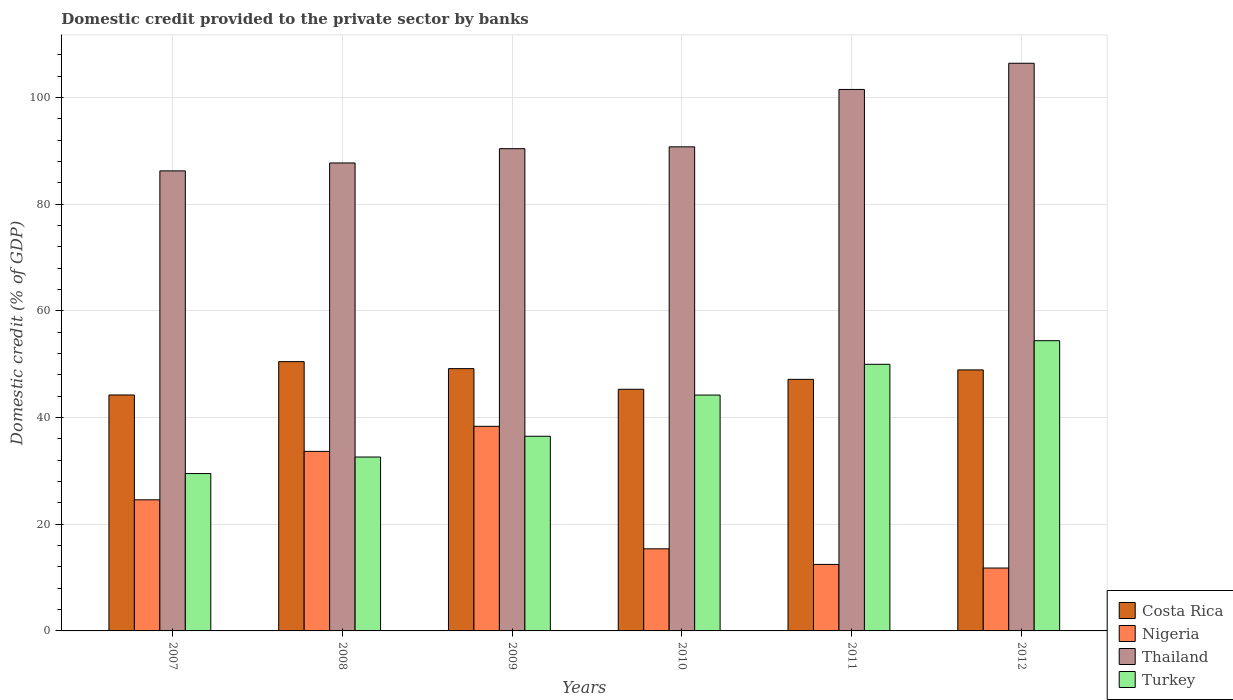How many groups of bars are there?
Your answer should be very brief. 6. Are the number of bars on each tick of the X-axis equal?
Offer a very short reply. Yes. How many bars are there on the 3rd tick from the right?
Provide a succinct answer. 4. What is the label of the 4th group of bars from the left?
Keep it short and to the point. 2010. What is the domestic credit provided to the private sector by banks in Turkey in 2011?
Offer a terse response. 49.97. Across all years, what is the maximum domestic credit provided to the private sector by banks in Costa Rica?
Offer a terse response. 50.47. Across all years, what is the minimum domestic credit provided to the private sector by banks in Thailand?
Your answer should be compact. 86.23. What is the total domestic credit provided to the private sector by banks in Thailand in the graph?
Provide a succinct answer. 562.93. What is the difference between the domestic credit provided to the private sector by banks in Turkey in 2010 and that in 2012?
Your answer should be very brief. -10.19. What is the difference between the domestic credit provided to the private sector by banks in Turkey in 2009 and the domestic credit provided to the private sector by banks in Thailand in 2012?
Offer a terse response. -69.91. What is the average domestic credit provided to the private sector by banks in Costa Rica per year?
Offer a very short reply. 47.54. In the year 2009, what is the difference between the domestic credit provided to the private sector by banks in Costa Rica and domestic credit provided to the private sector by banks in Thailand?
Keep it short and to the point. -41.23. What is the ratio of the domestic credit provided to the private sector by banks in Turkey in 2009 to that in 2010?
Your answer should be very brief. 0.83. What is the difference between the highest and the second highest domestic credit provided to the private sector by banks in Nigeria?
Your response must be concise. 4.69. What is the difference between the highest and the lowest domestic credit provided to the private sector by banks in Thailand?
Ensure brevity in your answer.  20.17. In how many years, is the domestic credit provided to the private sector by banks in Nigeria greater than the average domestic credit provided to the private sector by banks in Nigeria taken over all years?
Provide a succinct answer. 3. What does the 4th bar from the left in 2007 represents?
Offer a very short reply. Turkey. Is it the case that in every year, the sum of the domestic credit provided to the private sector by banks in Thailand and domestic credit provided to the private sector by banks in Turkey is greater than the domestic credit provided to the private sector by banks in Costa Rica?
Offer a terse response. Yes. How many bars are there?
Your answer should be compact. 24. How many years are there in the graph?
Your answer should be compact. 6. What is the difference between two consecutive major ticks on the Y-axis?
Your answer should be very brief. 20. Are the values on the major ticks of Y-axis written in scientific E-notation?
Provide a short and direct response. No. Does the graph contain any zero values?
Keep it short and to the point. No. Where does the legend appear in the graph?
Provide a short and direct response. Bottom right. How are the legend labels stacked?
Make the answer very short. Vertical. What is the title of the graph?
Your response must be concise. Domestic credit provided to the private sector by banks. Does "Samoa" appear as one of the legend labels in the graph?
Your response must be concise. No. What is the label or title of the Y-axis?
Give a very brief answer. Domestic credit (% of GDP). What is the Domestic credit (% of GDP) in Costa Rica in 2007?
Provide a short and direct response. 44.22. What is the Domestic credit (% of GDP) of Nigeria in 2007?
Ensure brevity in your answer.  24.57. What is the Domestic credit (% of GDP) in Thailand in 2007?
Provide a short and direct response. 86.23. What is the Domestic credit (% of GDP) of Turkey in 2007?
Give a very brief answer. 29.5. What is the Domestic credit (% of GDP) in Costa Rica in 2008?
Your answer should be very brief. 50.47. What is the Domestic credit (% of GDP) in Nigeria in 2008?
Your answer should be compact. 33.65. What is the Domestic credit (% of GDP) in Thailand in 2008?
Your response must be concise. 87.71. What is the Domestic credit (% of GDP) in Turkey in 2008?
Give a very brief answer. 32.59. What is the Domestic credit (% of GDP) of Costa Rica in 2009?
Give a very brief answer. 49.16. What is the Domestic credit (% of GDP) in Nigeria in 2009?
Your answer should be very brief. 38.35. What is the Domestic credit (% of GDP) in Thailand in 2009?
Keep it short and to the point. 90.38. What is the Domestic credit (% of GDP) of Turkey in 2009?
Offer a very short reply. 36.48. What is the Domestic credit (% of GDP) of Costa Rica in 2010?
Your response must be concise. 45.29. What is the Domestic credit (% of GDP) of Nigeria in 2010?
Your answer should be compact. 15.39. What is the Domestic credit (% of GDP) in Thailand in 2010?
Provide a succinct answer. 90.73. What is the Domestic credit (% of GDP) of Turkey in 2010?
Offer a terse response. 44.21. What is the Domestic credit (% of GDP) in Costa Rica in 2011?
Your response must be concise. 47.15. What is the Domestic credit (% of GDP) in Nigeria in 2011?
Your answer should be compact. 12.46. What is the Domestic credit (% of GDP) of Thailand in 2011?
Provide a short and direct response. 101.49. What is the Domestic credit (% of GDP) in Turkey in 2011?
Your answer should be compact. 49.97. What is the Domestic credit (% of GDP) of Costa Rica in 2012?
Keep it short and to the point. 48.92. What is the Domestic credit (% of GDP) in Nigeria in 2012?
Your response must be concise. 11.79. What is the Domestic credit (% of GDP) of Thailand in 2012?
Offer a terse response. 106.4. What is the Domestic credit (% of GDP) in Turkey in 2012?
Provide a succinct answer. 54.4. Across all years, what is the maximum Domestic credit (% of GDP) in Costa Rica?
Make the answer very short. 50.47. Across all years, what is the maximum Domestic credit (% of GDP) of Nigeria?
Provide a short and direct response. 38.35. Across all years, what is the maximum Domestic credit (% of GDP) in Thailand?
Offer a terse response. 106.4. Across all years, what is the maximum Domestic credit (% of GDP) in Turkey?
Give a very brief answer. 54.4. Across all years, what is the minimum Domestic credit (% of GDP) of Costa Rica?
Keep it short and to the point. 44.22. Across all years, what is the minimum Domestic credit (% of GDP) of Nigeria?
Your answer should be very brief. 11.79. Across all years, what is the minimum Domestic credit (% of GDP) of Thailand?
Your response must be concise. 86.23. Across all years, what is the minimum Domestic credit (% of GDP) of Turkey?
Ensure brevity in your answer.  29.5. What is the total Domestic credit (% of GDP) in Costa Rica in the graph?
Provide a succinct answer. 285.22. What is the total Domestic credit (% of GDP) in Nigeria in the graph?
Offer a very short reply. 136.22. What is the total Domestic credit (% of GDP) of Thailand in the graph?
Provide a short and direct response. 562.93. What is the total Domestic credit (% of GDP) of Turkey in the graph?
Provide a short and direct response. 247.15. What is the difference between the Domestic credit (% of GDP) of Costa Rica in 2007 and that in 2008?
Make the answer very short. -6.25. What is the difference between the Domestic credit (% of GDP) in Nigeria in 2007 and that in 2008?
Your answer should be compact. -9.08. What is the difference between the Domestic credit (% of GDP) in Thailand in 2007 and that in 2008?
Provide a succinct answer. -1.48. What is the difference between the Domestic credit (% of GDP) of Turkey in 2007 and that in 2008?
Ensure brevity in your answer.  -3.1. What is the difference between the Domestic credit (% of GDP) of Costa Rica in 2007 and that in 2009?
Your answer should be compact. -4.94. What is the difference between the Domestic credit (% of GDP) of Nigeria in 2007 and that in 2009?
Offer a very short reply. -13.78. What is the difference between the Domestic credit (% of GDP) of Thailand in 2007 and that in 2009?
Provide a short and direct response. -4.16. What is the difference between the Domestic credit (% of GDP) of Turkey in 2007 and that in 2009?
Your response must be concise. -6.99. What is the difference between the Domestic credit (% of GDP) of Costa Rica in 2007 and that in 2010?
Your response must be concise. -1.07. What is the difference between the Domestic credit (% of GDP) in Nigeria in 2007 and that in 2010?
Provide a succinct answer. 9.18. What is the difference between the Domestic credit (% of GDP) in Thailand in 2007 and that in 2010?
Your answer should be very brief. -4.5. What is the difference between the Domestic credit (% of GDP) in Turkey in 2007 and that in 2010?
Your answer should be very brief. -14.71. What is the difference between the Domestic credit (% of GDP) in Costa Rica in 2007 and that in 2011?
Your response must be concise. -2.93. What is the difference between the Domestic credit (% of GDP) of Nigeria in 2007 and that in 2011?
Offer a terse response. 12.11. What is the difference between the Domestic credit (% of GDP) of Thailand in 2007 and that in 2011?
Your answer should be very brief. -15.26. What is the difference between the Domestic credit (% of GDP) of Turkey in 2007 and that in 2011?
Your response must be concise. -20.48. What is the difference between the Domestic credit (% of GDP) in Costa Rica in 2007 and that in 2012?
Give a very brief answer. -4.7. What is the difference between the Domestic credit (% of GDP) of Nigeria in 2007 and that in 2012?
Provide a short and direct response. 12.78. What is the difference between the Domestic credit (% of GDP) of Thailand in 2007 and that in 2012?
Offer a very short reply. -20.17. What is the difference between the Domestic credit (% of GDP) of Turkey in 2007 and that in 2012?
Provide a succinct answer. -24.9. What is the difference between the Domestic credit (% of GDP) in Costa Rica in 2008 and that in 2009?
Your answer should be compact. 1.31. What is the difference between the Domestic credit (% of GDP) of Nigeria in 2008 and that in 2009?
Give a very brief answer. -4.69. What is the difference between the Domestic credit (% of GDP) in Thailand in 2008 and that in 2009?
Make the answer very short. -2.68. What is the difference between the Domestic credit (% of GDP) of Turkey in 2008 and that in 2009?
Give a very brief answer. -3.89. What is the difference between the Domestic credit (% of GDP) in Costa Rica in 2008 and that in 2010?
Give a very brief answer. 5.18. What is the difference between the Domestic credit (% of GDP) in Nigeria in 2008 and that in 2010?
Give a very brief answer. 18.26. What is the difference between the Domestic credit (% of GDP) of Thailand in 2008 and that in 2010?
Keep it short and to the point. -3.02. What is the difference between the Domestic credit (% of GDP) of Turkey in 2008 and that in 2010?
Ensure brevity in your answer.  -11.61. What is the difference between the Domestic credit (% of GDP) of Costa Rica in 2008 and that in 2011?
Offer a terse response. 3.32. What is the difference between the Domestic credit (% of GDP) of Nigeria in 2008 and that in 2011?
Offer a very short reply. 21.19. What is the difference between the Domestic credit (% of GDP) of Thailand in 2008 and that in 2011?
Your answer should be very brief. -13.78. What is the difference between the Domestic credit (% of GDP) of Turkey in 2008 and that in 2011?
Offer a terse response. -17.38. What is the difference between the Domestic credit (% of GDP) in Costa Rica in 2008 and that in 2012?
Make the answer very short. 1.55. What is the difference between the Domestic credit (% of GDP) in Nigeria in 2008 and that in 2012?
Offer a terse response. 21.87. What is the difference between the Domestic credit (% of GDP) of Thailand in 2008 and that in 2012?
Your response must be concise. -18.69. What is the difference between the Domestic credit (% of GDP) in Turkey in 2008 and that in 2012?
Make the answer very short. -21.8. What is the difference between the Domestic credit (% of GDP) of Costa Rica in 2009 and that in 2010?
Your answer should be compact. 3.87. What is the difference between the Domestic credit (% of GDP) of Nigeria in 2009 and that in 2010?
Make the answer very short. 22.96. What is the difference between the Domestic credit (% of GDP) of Thailand in 2009 and that in 2010?
Your answer should be very brief. -0.35. What is the difference between the Domestic credit (% of GDP) in Turkey in 2009 and that in 2010?
Ensure brevity in your answer.  -7.72. What is the difference between the Domestic credit (% of GDP) of Costa Rica in 2009 and that in 2011?
Offer a very short reply. 2.01. What is the difference between the Domestic credit (% of GDP) of Nigeria in 2009 and that in 2011?
Provide a succinct answer. 25.88. What is the difference between the Domestic credit (% of GDP) in Thailand in 2009 and that in 2011?
Ensure brevity in your answer.  -11.1. What is the difference between the Domestic credit (% of GDP) of Turkey in 2009 and that in 2011?
Ensure brevity in your answer.  -13.49. What is the difference between the Domestic credit (% of GDP) in Costa Rica in 2009 and that in 2012?
Ensure brevity in your answer.  0.24. What is the difference between the Domestic credit (% of GDP) of Nigeria in 2009 and that in 2012?
Your response must be concise. 26.56. What is the difference between the Domestic credit (% of GDP) of Thailand in 2009 and that in 2012?
Your answer should be very brief. -16.01. What is the difference between the Domestic credit (% of GDP) in Turkey in 2009 and that in 2012?
Make the answer very short. -17.91. What is the difference between the Domestic credit (% of GDP) in Costa Rica in 2010 and that in 2011?
Your answer should be compact. -1.86. What is the difference between the Domestic credit (% of GDP) of Nigeria in 2010 and that in 2011?
Offer a terse response. 2.93. What is the difference between the Domestic credit (% of GDP) of Thailand in 2010 and that in 2011?
Provide a succinct answer. -10.76. What is the difference between the Domestic credit (% of GDP) of Turkey in 2010 and that in 2011?
Offer a very short reply. -5.77. What is the difference between the Domestic credit (% of GDP) of Costa Rica in 2010 and that in 2012?
Provide a short and direct response. -3.63. What is the difference between the Domestic credit (% of GDP) of Nigeria in 2010 and that in 2012?
Give a very brief answer. 3.6. What is the difference between the Domestic credit (% of GDP) of Thailand in 2010 and that in 2012?
Ensure brevity in your answer.  -15.66. What is the difference between the Domestic credit (% of GDP) of Turkey in 2010 and that in 2012?
Make the answer very short. -10.19. What is the difference between the Domestic credit (% of GDP) of Costa Rica in 2011 and that in 2012?
Offer a very short reply. -1.77. What is the difference between the Domestic credit (% of GDP) in Nigeria in 2011 and that in 2012?
Provide a succinct answer. 0.68. What is the difference between the Domestic credit (% of GDP) in Thailand in 2011 and that in 2012?
Provide a short and direct response. -4.91. What is the difference between the Domestic credit (% of GDP) in Turkey in 2011 and that in 2012?
Ensure brevity in your answer.  -4.42. What is the difference between the Domestic credit (% of GDP) of Costa Rica in 2007 and the Domestic credit (% of GDP) of Nigeria in 2008?
Provide a short and direct response. 10.57. What is the difference between the Domestic credit (% of GDP) in Costa Rica in 2007 and the Domestic credit (% of GDP) in Thailand in 2008?
Make the answer very short. -43.49. What is the difference between the Domestic credit (% of GDP) of Costa Rica in 2007 and the Domestic credit (% of GDP) of Turkey in 2008?
Your response must be concise. 11.63. What is the difference between the Domestic credit (% of GDP) of Nigeria in 2007 and the Domestic credit (% of GDP) of Thailand in 2008?
Make the answer very short. -63.14. What is the difference between the Domestic credit (% of GDP) of Nigeria in 2007 and the Domestic credit (% of GDP) of Turkey in 2008?
Keep it short and to the point. -8.02. What is the difference between the Domestic credit (% of GDP) in Thailand in 2007 and the Domestic credit (% of GDP) in Turkey in 2008?
Your response must be concise. 53.63. What is the difference between the Domestic credit (% of GDP) of Costa Rica in 2007 and the Domestic credit (% of GDP) of Nigeria in 2009?
Keep it short and to the point. 5.87. What is the difference between the Domestic credit (% of GDP) in Costa Rica in 2007 and the Domestic credit (% of GDP) in Thailand in 2009?
Provide a succinct answer. -46.16. What is the difference between the Domestic credit (% of GDP) of Costa Rica in 2007 and the Domestic credit (% of GDP) of Turkey in 2009?
Provide a succinct answer. 7.74. What is the difference between the Domestic credit (% of GDP) of Nigeria in 2007 and the Domestic credit (% of GDP) of Thailand in 2009?
Offer a terse response. -65.81. What is the difference between the Domestic credit (% of GDP) of Nigeria in 2007 and the Domestic credit (% of GDP) of Turkey in 2009?
Keep it short and to the point. -11.91. What is the difference between the Domestic credit (% of GDP) of Thailand in 2007 and the Domestic credit (% of GDP) of Turkey in 2009?
Make the answer very short. 49.74. What is the difference between the Domestic credit (% of GDP) of Costa Rica in 2007 and the Domestic credit (% of GDP) of Nigeria in 2010?
Offer a terse response. 28.83. What is the difference between the Domestic credit (% of GDP) of Costa Rica in 2007 and the Domestic credit (% of GDP) of Thailand in 2010?
Your response must be concise. -46.51. What is the difference between the Domestic credit (% of GDP) in Costa Rica in 2007 and the Domestic credit (% of GDP) in Turkey in 2010?
Give a very brief answer. 0.02. What is the difference between the Domestic credit (% of GDP) of Nigeria in 2007 and the Domestic credit (% of GDP) of Thailand in 2010?
Your answer should be compact. -66.16. What is the difference between the Domestic credit (% of GDP) of Nigeria in 2007 and the Domestic credit (% of GDP) of Turkey in 2010?
Your answer should be very brief. -19.64. What is the difference between the Domestic credit (% of GDP) in Thailand in 2007 and the Domestic credit (% of GDP) in Turkey in 2010?
Your answer should be compact. 42.02. What is the difference between the Domestic credit (% of GDP) of Costa Rica in 2007 and the Domestic credit (% of GDP) of Nigeria in 2011?
Your answer should be very brief. 31.76. What is the difference between the Domestic credit (% of GDP) of Costa Rica in 2007 and the Domestic credit (% of GDP) of Thailand in 2011?
Keep it short and to the point. -57.26. What is the difference between the Domestic credit (% of GDP) of Costa Rica in 2007 and the Domestic credit (% of GDP) of Turkey in 2011?
Ensure brevity in your answer.  -5.75. What is the difference between the Domestic credit (% of GDP) of Nigeria in 2007 and the Domestic credit (% of GDP) of Thailand in 2011?
Offer a very short reply. -76.92. What is the difference between the Domestic credit (% of GDP) in Nigeria in 2007 and the Domestic credit (% of GDP) in Turkey in 2011?
Give a very brief answer. -25.4. What is the difference between the Domestic credit (% of GDP) of Thailand in 2007 and the Domestic credit (% of GDP) of Turkey in 2011?
Offer a very short reply. 36.25. What is the difference between the Domestic credit (% of GDP) in Costa Rica in 2007 and the Domestic credit (% of GDP) in Nigeria in 2012?
Offer a very short reply. 32.43. What is the difference between the Domestic credit (% of GDP) of Costa Rica in 2007 and the Domestic credit (% of GDP) of Thailand in 2012?
Offer a terse response. -62.17. What is the difference between the Domestic credit (% of GDP) of Costa Rica in 2007 and the Domestic credit (% of GDP) of Turkey in 2012?
Give a very brief answer. -10.17. What is the difference between the Domestic credit (% of GDP) in Nigeria in 2007 and the Domestic credit (% of GDP) in Thailand in 2012?
Your answer should be very brief. -81.82. What is the difference between the Domestic credit (% of GDP) of Nigeria in 2007 and the Domestic credit (% of GDP) of Turkey in 2012?
Offer a terse response. -29.82. What is the difference between the Domestic credit (% of GDP) in Thailand in 2007 and the Domestic credit (% of GDP) in Turkey in 2012?
Make the answer very short. 31.83. What is the difference between the Domestic credit (% of GDP) in Costa Rica in 2008 and the Domestic credit (% of GDP) in Nigeria in 2009?
Your answer should be very brief. 12.12. What is the difference between the Domestic credit (% of GDP) in Costa Rica in 2008 and the Domestic credit (% of GDP) in Thailand in 2009?
Your answer should be very brief. -39.91. What is the difference between the Domestic credit (% of GDP) in Costa Rica in 2008 and the Domestic credit (% of GDP) in Turkey in 2009?
Give a very brief answer. 13.99. What is the difference between the Domestic credit (% of GDP) of Nigeria in 2008 and the Domestic credit (% of GDP) of Thailand in 2009?
Your answer should be compact. -56.73. What is the difference between the Domestic credit (% of GDP) in Nigeria in 2008 and the Domestic credit (% of GDP) in Turkey in 2009?
Your answer should be very brief. -2.83. What is the difference between the Domestic credit (% of GDP) in Thailand in 2008 and the Domestic credit (% of GDP) in Turkey in 2009?
Keep it short and to the point. 51.22. What is the difference between the Domestic credit (% of GDP) in Costa Rica in 2008 and the Domestic credit (% of GDP) in Nigeria in 2010?
Give a very brief answer. 35.08. What is the difference between the Domestic credit (% of GDP) in Costa Rica in 2008 and the Domestic credit (% of GDP) in Thailand in 2010?
Your response must be concise. -40.26. What is the difference between the Domestic credit (% of GDP) of Costa Rica in 2008 and the Domestic credit (% of GDP) of Turkey in 2010?
Offer a very short reply. 6.27. What is the difference between the Domestic credit (% of GDP) of Nigeria in 2008 and the Domestic credit (% of GDP) of Thailand in 2010?
Provide a short and direct response. -57.08. What is the difference between the Domestic credit (% of GDP) in Nigeria in 2008 and the Domestic credit (% of GDP) in Turkey in 2010?
Ensure brevity in your answer.  -10.55. What is the difference between the Domestic credit (% of GDP) in Thailand in 2008 and the Domestic credit (% of GDP) in Turkey in 2010?
Give a very brief answer. 43.5. What is the difference between the Domestic credit (% of GDP) of Costa Rica in 2008 and the Domestic credit (% of GDP) of Nigeria in 2011?
Keep it short and to the point. 38.01. What is the difference between the Domestic credit (% of GDP) of Costa Rica in 2008 and the Domestic credit (% of GDP) of Thailand in 2011?
Ensure brevity in your answer.  -51.01. What is the difference between the Domestic credit (% of GDP) in Costa Rica in 2008 and the Domestic credit (% of GDP) in Turkey in 2011?
Provide a short and direct response. 0.5. What is the difference between the Domestic credit (% of GDP) of Nigeria in 2008 and the Domestic credit (% of GDP) of Thailand in 2011?
Your answer should be compact. -67.83. What is the difference between the Domestic credit (% of GDP) in Nigeria in 2008 and the Domestic credit (% of GDP) in Turkey in 2011?
Your answer should be very brief. -16.32. What is the difference between the Domestic credit (% of GDP) in Thailand in 2008 and the Domestic credit (% of GDP) in Turkey in 2011?
Provide a short and direct response. 37.73. What is the difference between the Domestic credit (% of GDP) of Costa Rica in 2008 and the Domestic credit (% of GDP) of Nigeria in 2012?
Provide a succinct answer. 38.68. What is the difference between the Domestic credit (% of GDP) of Costa Rica in 2008 and the Domestic credit (% of GDP) of Thailand in 2012?
Provide a short and direct response. -55.92. What is the difference between the Domestic credit (% of GDP) in Costa Rica in 2008 and the Domestic credit (% of GDP) in Turkey in 2012?
Keep it short and to the point. -3.92. What is the difference between the Domestic credit (% of GDP) in Nigeria in 2008 and the Domestic credit (% of GDP) in Thailand in 2012?
Ensure brevity in your answer.  -72.74. What is the difference between the Domestic credit (% of GDP) in Nigeria in 2008 and the Domestic credit (% of GDP) in Turkey in 2012?
Provide a short and direct response. -20.74. What is the difference between the Domestic credit (% of GDP) in Thailand in 2008 and the Domestic credit (% of GDP) in Turkey in 2012?
Your response must be concise. 33.31. What is the difference between the Domestic credit (% of GDP) in Costa Rica in 2009 and the Domestic credit (% of GDP) in Nigeria in 2010?
Offer a very short reply. 33.77. What is the difference between the Domestic credit (% of GDP) in Costa Rica in 2009 and the Domestic credit (% of GDP) in Thailand in 2010?
Keep it short and to the point. -41.57. What is the difference between the Domestic credit (% of GDP) in Costa Rica in 2009 and the Domestic credit (% of GDP) in Turkey in 2010?
Your answer should be very brief. 4.95. What is the difference between the Domestic credit (% of GDP) of Nigeria in 2009 and the Domestic credit (% of GDP) of Thailand in 2010?
Make the answer very short. -52.38. What is the difference between the Domestic credit (% of GDP) in Nigeria in 2009 and the Domestic credit (% of GDP) in Turkey in 2010?
Provide a succinct answer. -5.86. What is the difference between the Domestic credit (% of GDP) of Thailand in 2009 and the Domestic credit (% of GDP) of Turkey in 2010?
Offer a terse response. 46.18. What is the difference between the Domestic credit (% of GDP) in Costa Rica in 2009 and the Domestic credit (% of GDP) in Nigeria in 2011?
Keep it short and to the point. 36.69. What is the difference between the Domestic credit (% of GDP) in Costa Rica in 2009 and the Domestic credit (% of GDP) in Thailand in 2011?
Your answer should be very brief. -52.33. What is the difference between the Domestic credit (% of GDP) of Costa Rica in 2009 and the Domestic credit (% of GDP) of Turkey in 2011?
Provide a short and direct response. -0.81. What is the difference between the Domestic credit (% of GDP) of Nigeria in 2009 and the Domestic credit (% of GDP) of Thailand in 2011?
Make the answer very short. -63.14. What is the difference between the Domestic credit (% of GDP) in Nigeria in 2009 and the Domestic credit (% of GDP) in Turkey in 2011?
Your answer should be compact. -11.62. What is the difference between the Domestic credit (% of GDP) of Thailand in 2009 and the Domestic credit (% of GDP) of Turkey in 2011?
Offer a very short reply. 40.41. What is the difference between the Domestic credit (% of GDP) of Costa Rica in 2009 and the Domestic credit (% of GDP) of Nigeria in 2012?
Offer a terse response. 37.37. What is the difference between the Domestic credit (% of GDP) of Costa Rica in 2009 and the Domestic credit (% of GDP) of Thailand in 2012?
Offer a very short reply. -57.24. What is the difference between the Domestic credit (% of GDP) of Costa Rica in 2009 and the Domestic credit (% of GDP) of Turkey in 2012?
Your response must be concise. -5.24. What is the difference between the Domestic credit (% of GDP) in Nigeria in 2009 and the Domestic credit (% of GDP) in Thailand in 2012?
Keep it short and to the point. -68.05. What is the difference between the Domestic credit (% of GDP) of Nigeria in 2009 and the Domestic credit (% of GDP) of Turkey in 2012?
Your answer should be compact. -16.05. What is the difference between the Domestic credit (% of GDP) of Thailand in 2009 and the Domestic credit (% of GDP) of Turkey in 2012?
Offer a terse response. 35.99. What is the difference between the Domestic credit (% of GDP) of Costa Rica in 2010 and the Domestic credit (% of GDP) of Nigeria in 2011?
Ensure brevity in your answer.  32.83. What is the difference between the Domestic credit (% of GDP) of Costa Rica in 2010 and the Domestic credit (% of GDP) of Thailand in 2011?
Your response must be concise. -56.19. What is the difference between the Domestic credit (% of GDP) in Costa Rica in 2010 and the Domestic credit (% of GDP) in Turkey in 2011?
Provide a succinct answer. -4.68. What is the difference between the Domestic credit (% of GDP) of Nigeria in 2010 and the Domestic credit (% of GDP) of Thailand in 2011?
Offer a very short reply. -86.1. What is the difference between the Domestic credit (% of GDP) of Nigeria in 2010 and the Domestic credit (% of GDP) of Turkey in 2011?
Make the answer very short. -34.58. What is the difference between the Domestic credit (% of GDP) of Thailand in 2010 and the Domestic credit (% of GDP) of Turkey in 2011?
Offer a very short reply. 40.76. What is the difference between the Domestic credit (% of GDP) in Costa Rica in 2010 and the Domestic credit (% of GDP) in Nigeria in 2012?
Offer a very short reply. 33.5. What is the difference between the Domestic credit (% of GDP) of Costa Rica in 2010 and the Domestic credit (% of GDP) of Thailand in 2012?
Provide a succinct answer. -61.1. What is the difference between the Domestic credit (% of GDP) of Costa Rica in 2010 and the Domestic credit (% of GDP) of Turkey in 2012?
Provide a succinct answer. -9.1. What is the difference between the Domestic credit (% of GDP) of Nigeria in 2010 and the Domestic credit (% of GDP) of Thailand in 2012?
Make the answer very short. -91. What is the difference between the Domestic credit (% of GDP) of Nigeria in 2010 and the Domestic credit (% of GDP) of Turkey in 2012?
Offer a very short reply. -39.01. What is the difference between the Domestic credit (% of GDP) in Thailand in 2010 and the Domestic credit (% of GDP) in Turkey in 2012?
Keep it short and to the point. 36.33. What is the difference between the Domestic credit (% of GDP) in Costa Rica in 2011 and the Domestic credit (% of GDP) in Nigeria in 2012?
Provide a short and direct response. 35.36. What is the difference between the Domestic credit (% of GDP) of Costa Rica in 2011 and the Domestic credit (% of GDP) of Thailand in 2012?
Your response must be concise. -59.25. What is the difference between the Domestic credit (% of GDP) in Costa Rica in 2011 and the Domestic credit (% of GDP) in Turkey in 2012?
Give a very brief answer. -7.25. What is the difference between the Domestic credit (% of GDP) in Nigeria in 2011 and the Domestic credit (% of GDP) in Thailand in 2012?
Ensure brevity in your answer.  -93.93. What is the difference between the Domestic credit (% of GDP) of Nigeria in 2011 and the Domestic credit (% of GDP) of Turkey in 2012?
Your response must be concise. -41.93. What is the difference between the Domestic credit (% of GDP) in Thailand in 2011 and the Domestic credit (% of GDP) in Turkey in 2012?
Your answer should be compact. 47.09. What is the average Domestic credit (% of GDP) of Costa Rica per year?
Your answer should be very brief. 47.54. What is the average Domestic credit (% of GDP) in Nigeria per year?
Offer a very short reply. 22.7. What is the average Domestic credit (% of GDP) in Thailand per year?
Provide a short and direct response. 93.82. What is the average Domestic credit (% of GDP) in Turkey per year?
Provide a succinct answer. 41.19. In the year 2007, what is the difference between the Domestic credit (% of GDP) in Costa Rica and Domestic credit (% of GDP) in Nigeria?
Offer a very short reply. 19.65. In the year 2007, what is the difference between the Domestic credit (% of GDP) in Costa Rica and Domestic credit (% of GDP) in Thailand?
Your answer should be compact. -42. In the year 2007, what is the difference between the Domestic credit (% of GDP) in Costa Rica and Domestic credit (% of GDP) in Turkey?
Offer a terse response. 14.73. In the year 2007, what is the difference between the Domestic credit (% of GDP) in Nigeria and Domestic credit (% of GDP) in Thailand?
Give a very brief answer. -61.65. In the year 2007, what is the difference between the Domestic credit (% of GDP) of Nigeria and Domestic credit (% of GDP) of Turkey?
Offer a very short reply. -4.92. In the year 2007, what is the difference between the Domestic credit (% of GDP) of Thailand and Domestic credit (% of GDP) of Turkey?
Keep it short and to the point. 56.73. In the year 2008, what is the difference between the Domestic credit (% of GDP) of Costa Rica and Domestic credit (% of GDP) of Nigeria?
Make the answer very short. 16.82. In the year 2008, what is the difference between the Domestic credit (% of GDP) of Costa Rica and Domestic credit (% of GDP) of Thailand?
Give a very brief answer. -37.24. In the year 2008, what is the difference between the Domestic credit (% of GDP) of Costa Rica and Domestic credit (% of GDP) of Turkey?
Offer a terse response. 17.88. In the year 2008, what is the difference between the Domestic credit (% of GDP) of Nigeria and Domestic credit (% of GDP) of Thailand?
Ensure brevity in your answer.  -54.05. In the year 2008, what is the difference between the Domestic credit (% of GDP) of Nigeria and Domestic credit (% of GDP) of Turkey?
Make the answer very short. 1.06. In the year 2008, what is the difference between the Domestic credit (% of GDP) in Thailand and Domestic credit (% of GDP) in Turkey?
Offer a very short reply. 55.11. In the year 2009, what is the difference between the Domestic credit (% of GDP) in Costa Rica and Domestic credit (% of GDP) in Nigeria?
Give a very brief answer. 10.81. In the year 2009, what is the difference between the Domestic credit (% of GDP) in Costa Rica and Domestic credit (% of GDP) in Thailand?
Provide a succinct answer. -41.23. In the year 2009, what is the difference between the Domestic credit (% of GDP) of Costa Rica and Domestic credit (% of GDP) of Turkey?
Offer a very short reply. 12.67. In the year 2009, what is the difference between the Domestic credit (% of GDP) of Nigeria and Domestic credit (% of GDP) of Thailand?
Ensure brevity in your answer.  -52.04. In the year 2009, what is the difference between the Domestic credit (% of GDP) in Nigeria and Domestic credit (% of GDP) in Turkey?
Provide a succinct answer. 1.86. In the year 2009, what is the difference between the Domestic credit (% of GDP) in Thailand and Domestic credit (% of GDP) in Turkey?
Provide a succinct answer. 53.9. In the year 2010, what is the difference between the Domestic credit (% of GDP) of Costa Rica and Domestic credit (% of GDP) of Nigeria?
Your answer should be compact. 29.9. In the year 2010, what is the difference between the Domestic credit (% of GDP) in Costa Rica and Domestic credit (% of GDP) in Thailand?
Provide a short and direct response. -45.44. In the year 2010, what is the difference between the Domestic credit (% of GDP) in Costa Rica and Domestic credit (% of GDP) in Turkey?
Give a very brief answer. 1.08. In the year 2010, what is the difference between the Domestic credit (% of GDP) of Nigeria and Domestic credit (% of GDP) of Thailand?
Your response must be concise. -75.34. In the year 2010, what is the difference between the Domestic credit (% of GDP) of Nigeria and Domestic credit (% of GDP) of Turkey?
Make the answer very short. -28.82. In the year 2010, what is the difference between the Domestic credit (% of GDP) of Thailand and Domestic credit (% of GDP) of Turkey?
Make the answer very short. 46.52. In the year 2011, what is the difference between the Domestic credit (% of GDP) in Costa Rica and Domestic credit (% of GDP) in Nigeria?
Provide a short and direct response. 34.69. In the year 2011, what is the difference between the Domestic credit (% of GDP) of Costa Rica and Domestic credit (% of GDP) of Thailand?
Offer a very short reply. -54.34. In the year 2011, what is the difference between the Domestic credit (% of GDP) in Costa Rica and Domestic credit (% of GDP) in Turkey?
Provide a succinct answer. -2.82. In the year 2011, what is the difference between the Domestic credit (% of GDP) of Nigeria and Domestic credit (% of GDP) of Thailand?
Give a very brief answer. -89.02. In the year 2011, what is the difference between the Domestic credit (% of GDP) in Nigeria and Domestic credit (% of GDP) in Turkey?
Provide a short and direct response. -37.51. In the year 2011, what is the difference between the Domestic credit (% of GDP) in Thailand and Domestic credit (% of GDP) in Turkey?
Your response must be concise. 51.51. In the year 2012, what is the difference between the Domestic credit (% of GDP) in Costa Rica and Domestic credit (% of GDP) in Nigeria?
Ensure brevity in your answer.  37.13. In the year 2012, what is the difference between the Domestic credit (% of GDP) in Costa Rica and Domestic credit (% of GDP) in Thailand?
Keep it short and to the point. -57.48. In the year 2012, what is the difference between the Domestic credit (% of GDP) of Costa Rica and Domestic credit (% of GDP) of Turkey?
Offer a very short reply. -5.48. In the year 2012, what is the difference between the Domestic credit (% of GDP) of Nigeria and Domestic credit (% of GDP) of Thailand?
Provide a short and direct response. -94.61. In the year 2012, what is the difference between the Domestic credit (% of GDP) in Nigeria and Domestic credit (% of GDP) in Turkey?
Ensure brevity in your answer.  -42.61. In the year 2012, what is the difference between the Domestic credit (% of GDP) in Thailand and Domestic credit (% of GDP) in Turkey?
Your answer should be very brief. 52. What is the ratio of the Domestic credit (% of GDP) of Costa Rica in 2007 to that in 2008?
Your response must be concise. 0.88. What is the ratio of the Domestic credit (% of GDP) in Nigeria in 2007 to that in 2008?
Offer a terse response. 0.73. What is the ratio of the Domestic credit (% of GDP) in Thailand in 2007 to that in 2008?
Keep it short and to the point. 0.98. What is the ratio of the Domestic credit (% of GDP) in Turkey in 2007 to that in 2008?
Your answer should be compact. 0.91. What is the ratio of the Domestic credit (% of GDP) in Costa Rica in 2007 to that in 2009?
Your answer should be compact. 0.9. What is the ratio of the Domestic credit (% of GDP) in Nigeria in 2007 to that in 2009?
Offer a terse response. 0.64. What is the ratio of the Domestic credit (% of GDP) of Thailand in 2007 to that in 2009?
Offer a terse response. 0.95. What is the ratio of the Domestic credit (% of GDP) of Turkey in 2007 to that in 2009?
Offer a very short reply. 0.81. What is the ratio of the Domestic credit (% of GDP) in Costa Rica in 2007 to that in 2010?
Offer a very short reply. 0.98. What is the ratio of the Domestic credit (% of GDP) in Nigeria in 2007 to that in 2010?
Offer a very short reply. 1.6. What is the ratio of the Domestic credit (% of GDP) in Thailand in 2007 to that in 2010?
Offer a terse response. 0.95. What is the ratio of the Domestic credit (% of GDP) of Turkey in 2007 to that in 2010?
Your response must be concise. 0.67. What is the ratio of the Domestic credit (% of GDP) of Costa Rica in 2007 to that in 2011?
Provide a succinct answer. 0.94. What is the ratio of the Domestic credit (% of GDP) of Nigeria in 2007 to that in 2011?
Provide a succinct answer. 1.97. What is the ratio of the Domestic credit (% of GDP) in Thailand in 2007 to that in 2011?
Make the answer very short. 0.85. What is the ratio of the Domestic credit (% of GDP) of Turkey in 2007 to that in 2011?
Your answer should be very brief. 0.59. What is the ratio of the Domestic credit (% of GDP) in Costa Rica in 2007 to that in 2012?
Give a very brief answer. 0.9. What is the ratio of the Domestic credit (% of GDP) in Nigeria in 2007 to that in 2012?
Keep it short and to the point. 2.08. What is the ratio of the Domestic credit (% of GDP) in Thailand in 2007 to that in 2012?
Ensure brevity in your answer.  0.81. What is the ratio of the Domestic credit (% of GDP) of Turkey in 2007 to that in 2012?
Provide a succinct answer. 0.54. What is the ratio of the Domestic credit (% of GDP) of Costa Rica in 2008 to that in 2009?
Provide a short and direct response. 1.03. What is the ratio of the Domestic credit (% of GDP) in Nigeria in 2008 to that in 2009?
Your answer should be compact. 0.88. What is the ratio of the Domestic credit (% of GDP) in Thailand in 2008 to that in 2009?
Offer a very short reply. 0.97. What is the ratio of the Domestic credit (% of GDP) in Turkey in 2008 to that in 2009?
Offer a terse response. 0.89. What is the ratio of the Domestic credit (% of GDP) in Costa Rica in 2008 to that in 2010?
Your answer should be very brief. 1.11. What is the ratio of the Domestic credit (% of GDP) of Nigeria in 2008 to that in 2010?
Offer a terse response. 2.19. What is the ratio of the Domestic credit (% of GDP) in Thailand in 2008 to that in 2010?
Make the answer very short. 0.97. What is the ratio of the Domestic credit (% of GDP) of Turkey in 2008 to that in 2010?
Your answer should be compact. 0.74. What is the ratio of the Domestic credit (% of GDP) in Costa Rica in 2008 to that in 2011?
Offer a very short reply. 1.07. What is the ratio of the Domestic credit (% of GDP) in Nigeria in 2008 to that in 2011?
Ensure brevity in your answer.  2.7. What is the ratio of the Domestic credit (% of GDP) in Thailand in 2008 to that in 2011?
Keep it short and to the point. 0.86. What is the ratio of the Domestic credit (% of GDP) in Turkey in 2008 to that in 2011?
Offer a terse response. 0.65. What is the ratio of the Domestic credit (% of GDP) in Costa Rica in 2008 to that in 2012?
Give a very brief answer. 1.03. What is the ratio of the Domestic credit (% of GDP) in Nigeria in 2008 to that in 2012?
Provide a succinct answer. 2.85. What is the ratio of the Domestic credit (% of GDP) of Thailand in 2008 to that in 2012?
Give a very brief answer. 0.82. What is the ratio of the Domestic credit (% of GDP) of Turkey in 2008 to that in 2012?
Make the answer very short. 0.6. What is the ratio of the Domestic credit (% of GDP) of Costa Rica in 2009 to that in 2010?
Offer a terse response. 1.09. What is the ratio of the Domestic credit (% of GDP) of Nigeria in 2009 to that in 2010?
Your answer should be compact. 2.49. What is the ratio of the Domestic credit (% of GDP) in Turkey in 2009 to that in 2010?
Ensure brevity in your answer.  0.83. What is the ratio of the Domestic credit (% of GDP) in Costa Rica in 2009 to that in 2011?
Provide a succinct answer. 1.04. What is the ratio of the Domestic credit (% of GDP) in Nigeria in 2009 to that in 2011?
Provide a short and direct response. 3.08. What is the ratio of the Domestic credit (% of GDP) in Thailand in 2009 to that in 2011?
Keep it short and to the point. 0.89. What is the ratio of the Domestic credit (% of GDP) in Turkey in 2009 to that in 2011?
Give a very brief answer. 0.73. What is the ratio of the Domestic credit (% of GDP) in Nigeria in 2009 to that in 2012?
Give a very brief answer. 3.25. What is the ratio of the Domestic credit (% of GDP) of Thailand in 2009 to that in 2012?
Provide a short and direct response. 0.85. What is the ratio of the Domestic credit (% of GDP) of Turkey in 2009 to that in 2012?
Give a very brief answer. 0.67. What is the ratio of the Domestic credit (% of GDP) in Costa Rica in 2010 to that in 2011?
Make the answer very short. 0.96. What is the ratio of the Domestic credit (% of GDP) in Nigeria in 2010 to that in 2011?
Give a very brief answer. 1.23. What is the ratio of the Domestic credit (% of GDP) of Thailand in 2010 to that in 2011?
Provide a succinct answer. 0.89. What is the ratio of the Domestic credit (% of GDP) of Turkey in 2010 to that in 2011?
Your answer should be very brief. 0.88. What is the ratio of the Domestic credit (% of GDP) in Costa Rica in 2010 to that in 2012?
Give a very brief answer. 0.93. What is the ratio of the Domestic credit (% of GDP) in Nigeria in 2010 to that in 2012?
Your answer should be very brief. 1.31. What is the ratio of the Domestic credit (% of GDP) in Thailand in 2010 to that in 2012?
Provide a succinct answer. 0.85. What is the ratio of the Domestic credit (% of GDP) of Turkey in 2010 to that in 2012?
Keep it short and to the point. 0.81. What is the ratio of the Domestic credit (% of GDP) in Costa Rica in 2011 to that in 2012?
Offer a very short reply. 0.96. What is the ratio of the Domestic credit (% of GDP) in Nigeria in 2011 to that in 2012?
Your response must be concise. 1.06. What is the ratio of the Domestic credit (% of GDP) in Thailand in 2011 to that in 2012?
Provide a short and direct response. 0.95. What is the ratio of the Domestic credit (% of GDP) in Turkey in 2011 to that in 2012?
Provide a short and direct response. 0.92. What is the difference between the highest and the second highest Domestic credit (% of GDP) in Costa Rica?
Give a very brief answer. 1.31. What is the difference between the highest and the second highest Domestic credit (% of GDP) in Nigeria?
Offer a terse response. 4.69. What is the difference between the highest and the second highest Domestic credit (% of GDP) of Thailand?
Your answer should be compact. 4.91. What is the difference between the highest and the second highest Domestic credit (% of GDP) of Turkey?
Offer a terse response. 4.42. What is the difference between the highest and the lowest Domestic credit (% of GDP) in Costa Rica?
Give a very brief answer. 6.25. What is the difference between the highest and the lowest Domestic credit (% of GDP) in Nigeria?
Keep it short and to the point. 26.56. What is the difference between the highest and the lowest Domestic credit (% of GDP) in Thailand?
Provide a short and direct response. 20.17. What is the difference between the highest and the lowest Domestic credit (% of GDP) in Turkey?
Ensure brevity in your answer.  24.9. 